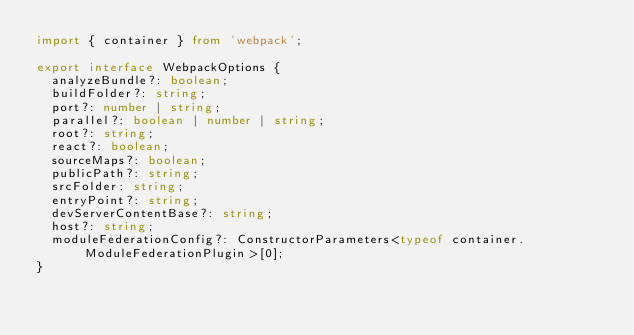<code> <loc_0><loc_0><loc_500><loc_500><_TypeScript_>import { container } from 'webpack';

export interface WebpackOptions {
  analyzeBundle?: boolean;
  buildFolder?: string;
  port?: number | string;
  parallel?: boolean | number | string;
  root?: string;
  react?: boolean;
  sourceMaps?: boolean;
  publicPath?: string;
  srcFolder: string;
  entryPoint?: string;
  devServerContentBase?: string;
  host?: string;
  moduleFederationConfig?: ConstructorParameters<typeof container.ModuleFederationPlugin>[0];
}
</code> 